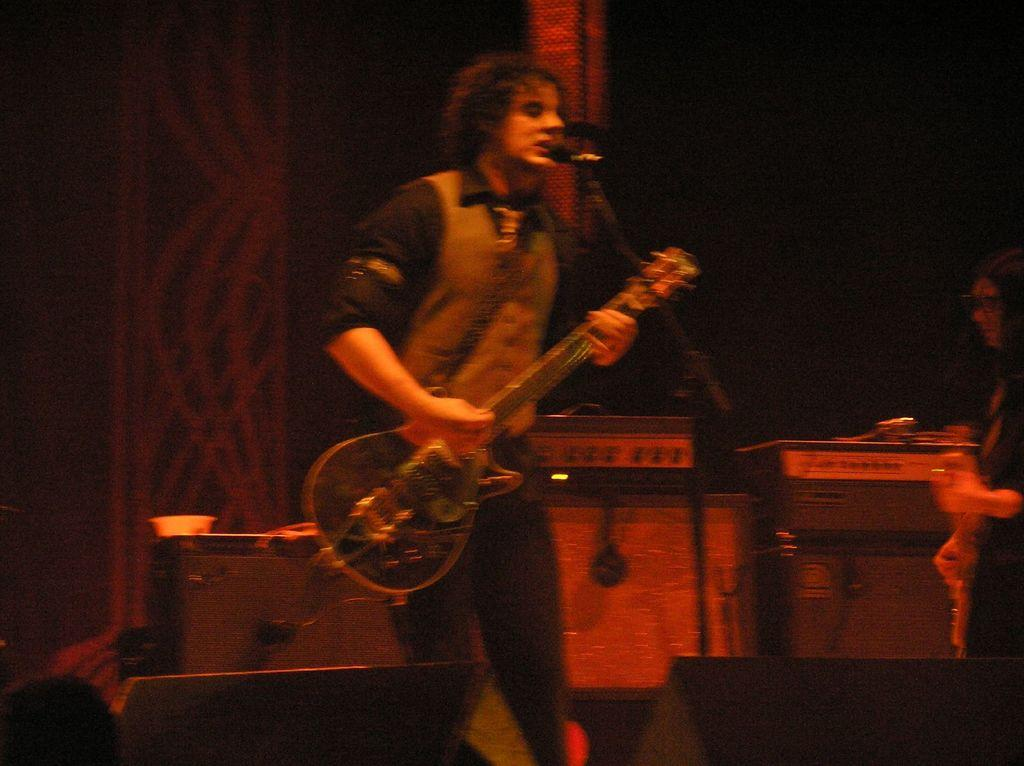What is the man in the image doing? The man is playing a guitar in the image. What object is present that is commonly used for amplifying sound? There is a microphone in the image. Who else is present in the image besides the man playing the guitar? There is a woman in the image. What other objects in the image are related to music? There are musical instruments in the image. What type of calculator is the man using while playing the guitar in the image? There is no calculator present in the image; the man is playing a guitar without any additional devices. 